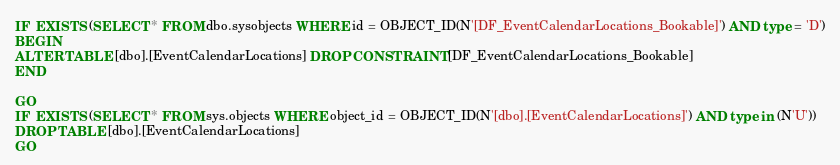Convert code to text. <code><loc_0><loc_0><loc_500><loc_500><_SQL_>IF  EXISTS (SELECT * FROM dbo.sysobjects WHERE id = OBJECT_ID(N'[DF_EventCalendarLocations_Bookable]') AND type = 'D')
BEGIN
ALTER TABLE [dbo].[EventCalendarLocations] DROP CONSTRAINT [DF_EventCalendarLocations_Bookable]
END

GO
IF  EXISTS (SELECT * FROM sys.objects WHERE object_id = OBJECT_ID(N'[dbo].[EventCalendarLocations]') AND type in (N'U'))
DROP TABLE [dbo].[EventCalendarLocations]
GO
</code> 